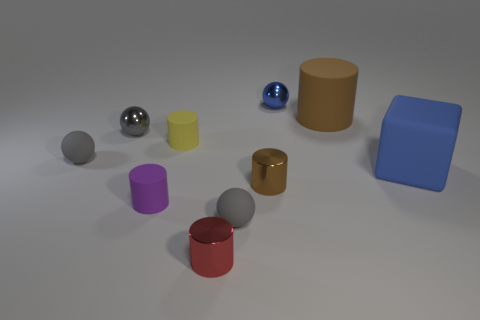Subtract all gray balls. How many were subtracted if there are1gray balls left? 2 Subtract all red cylinders. How many gray balls are left? 3 Subtract 1 cylinders. How many cylinders are left? 4 Subtract all cyan cylinders. Subtract all cyan blocks. How many cylinders are left? 5 Subtract all cubes. How many objects are left? 9 Subtract 0 red blocks. How many objects are left? 10 Subtract all gray matte things. Subtract all gray rubber objects. How many objects are left? 6 Add 4 purple objects. How many purple objects are left? 5 Add 2 tiny red metallic cylinders. How many tiny red metallic cylinders exist? 3 